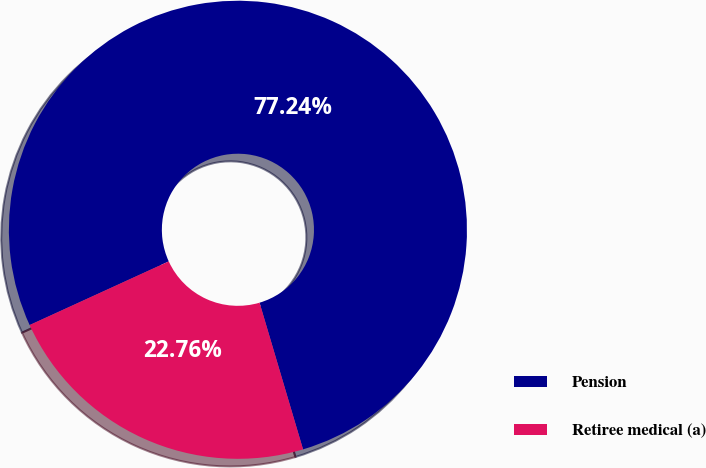<chart> <loc_0><loc_0><loc_500><loc_500><pie_chart><fcel>Pension<fcel>Retiree medical (a)<nl><fcel>77.24%<fcel>22.76%<nl></chart> 